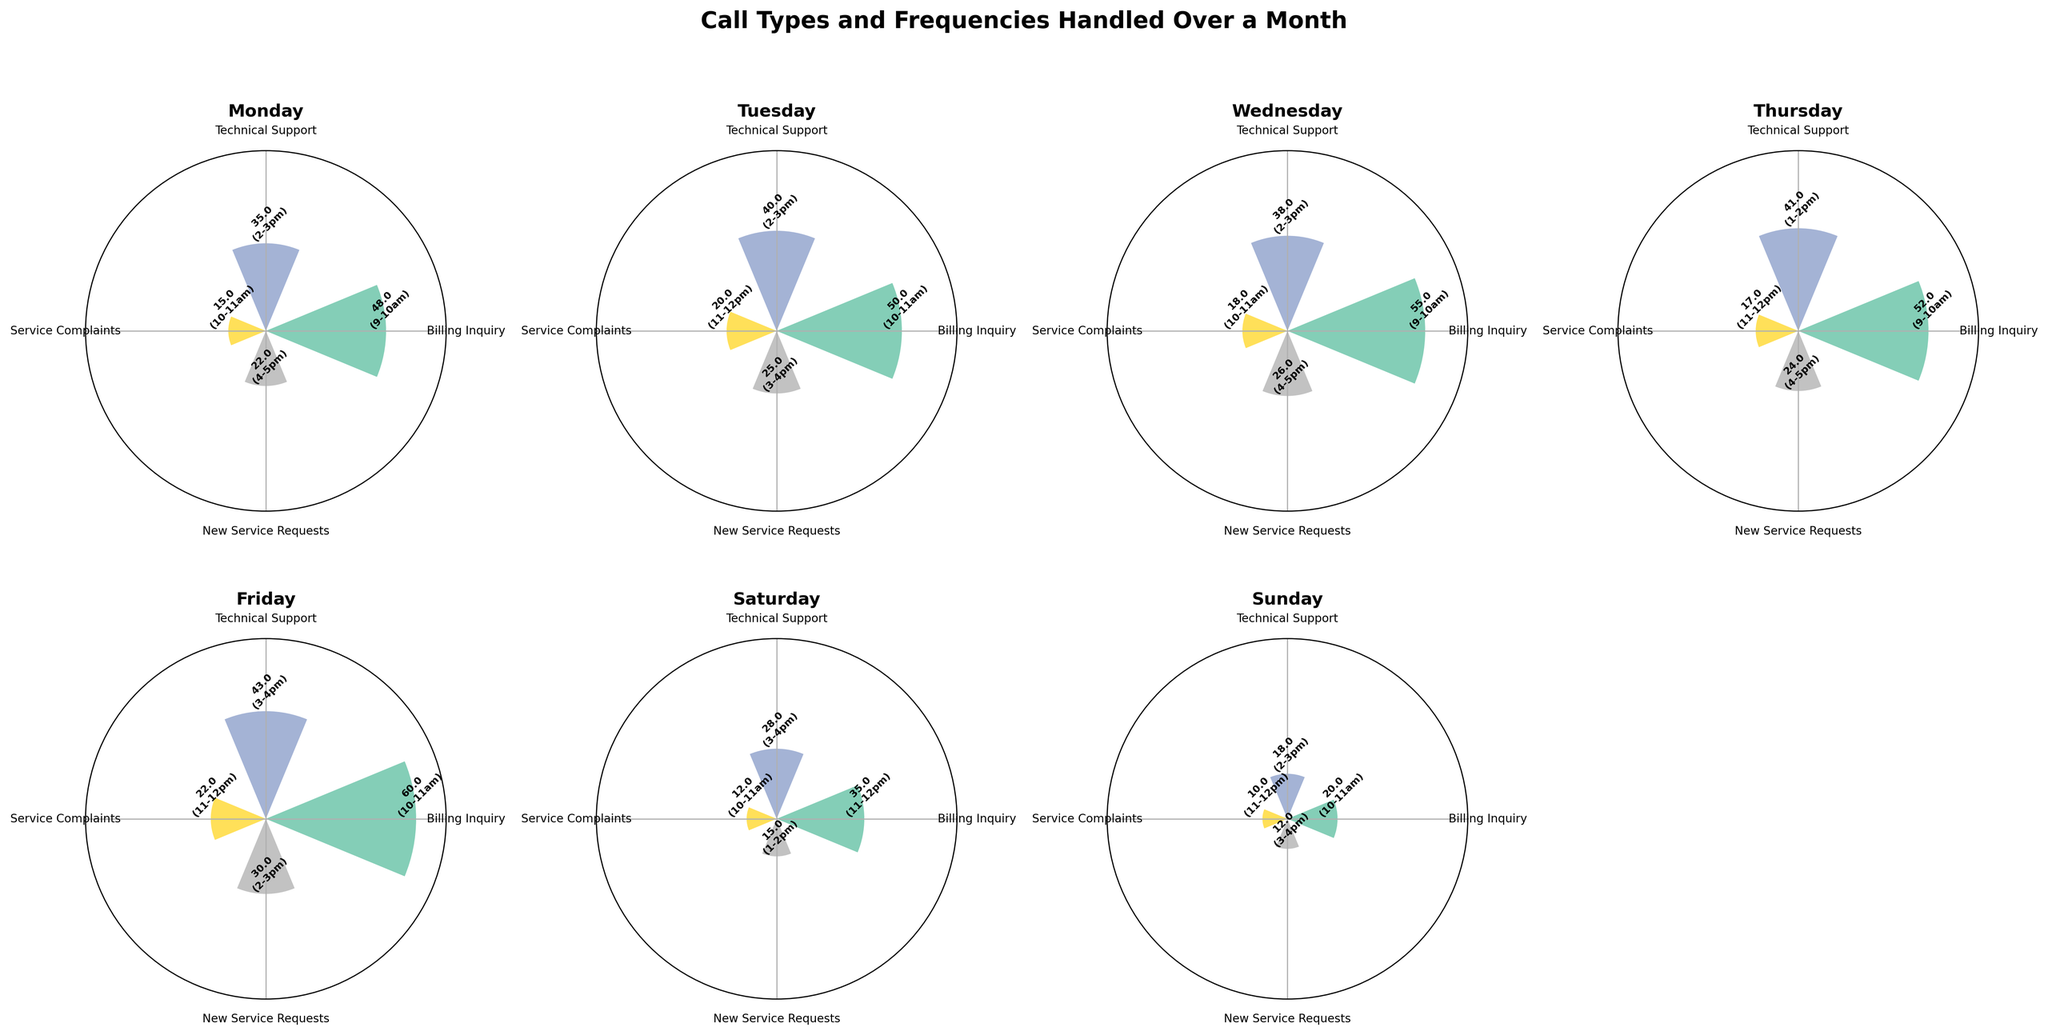What is the title of the plot? The title is typically displayed at the top center of the plot. In this case, it should be clear from the provided data and code that the title is 'Call Types and Frequencies Handled Over a Month'.
Answer: Call Types and Frequencies Handled Over a Month Which day has the highest frequency for 'Billing Inquiry' calls? By visually inspecting each subplot, the day with the tallest bar for 'Billing Inquiry' will indicate the highest frequency. On Friday, the 'Billing Inquiry' bar is the tallest.
Answer: Friday What is the peak hour for 'Technical Support' calls on Tuesday? In the subplot for Tuesday, look for the 'Technical Support' segment and read the time label provided at the tip of the bar. The peak hour noted should be '2-3pm'.
Answer: 2-3pm On which day do 'New Service Requests' calls peak at 1-2pm? By examining each day’s subplot, we can see which day has '1-2pm' annotated next to the 'New Service Requests' bar. The only occurrence is on Saturday.
Answer: Saturday What is the average frequency of 'Service Complaints' across all weekdays? Average frequency is calculated by summing the frequencies of 'Service Complaints' for all days and dividing by the number of days. The values are 15, 20, 18, 17, 22, 12, 10 summing to 114. Dividing by 7 days gives approximately 16.29.
Answer: 16.29 Which call type has the least frequency on Sunday? Inspect the subplot for Sunday and identify the smallest bar among all call types. The smallest bar belongs to 'Service Complaints'.
Answer: Service Complaints On Thursday, are there more 'Billing Inquiry' calls or 'Technical Support' calls? Comparing the bars for 'Billing Inquiry' and 'Technical Support' in the Thursday subplot shows 'Billing Inquiry' having a taller bar.
Answer: Billing Inquiry Which call type has the most uniform (least varied) frequencies across the weekdays? By visually comparing the heights of bars for each call type across all subplots, 'New Service Requests' appears to have the least variation in height from one day to another.
Answer: New Service Requests How many call types are displayed in each subplot? Each subplot corresponds to a weekday and displays bars for each call type. From the provided data, there are four different call types: Billing Inquiry, Technical Support, Service Complaints, and New Service Requests.
Answer: 4 